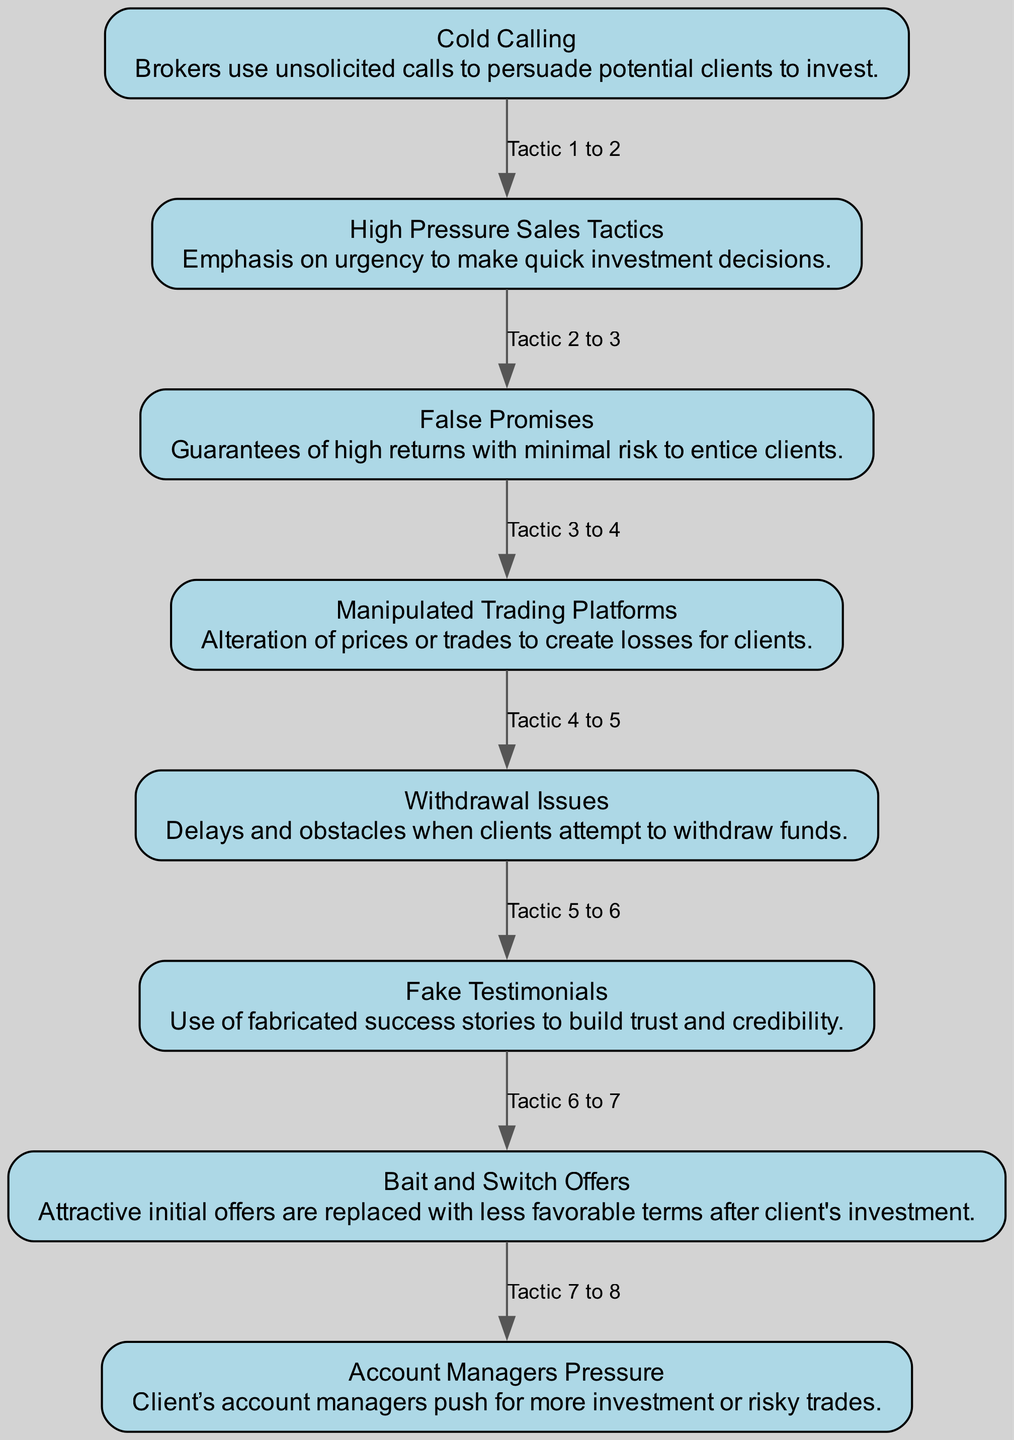What is the first tactic listed in the diagram? The first element in the flow chart is "Cold Calling," which serves as the starting point for understanding fraudulent tactics.
Answer: Cold Calling How many total tactics are presented in the diagram? Counting the elements mentioned in the diagram, there are eight tactics listed.
Answer: 8 What is the relationship between "Fake Testimonials" and "Withdrawal Issues"? "Fake Testimonials" is the sixth tactic and is followed by "Withdrawal Issues," which is the fifth tactic in the order. This indicates that they are sequential in the flow.
Answer: Sequential What tactic is associated with high returns and minimal risk? The tactic describing high returns with minimal risk is "False Promises." It aims to draw in clients by providing unrealistic expectations.
Answer: False Promises What is the last tactic mentioned in the flow chart? The final tactic in the diagram is "Account Managers Pressure," which aims to coerce clients into additional investments or risky trades.
Answer: Account Managers Pressure Which tactic involves delays when withdrawing funds? The tactic that highlights issues when attempting to withdraw funds is "Withdrawal Issues," which focuses on the challenges clients face during this process.
Answer: Withdrawal Issues Identify a tactic used to manipulate trading conditions. The tactic that manipulates trading conditions is "Manipulated Trading Platforms," where brokers alter prices or trades leading to client losses.
Answer: Manipulated Trading Platforms Which two tactics directly focus on pressuring clients? The tactics "High Pressure Sales Tactics" and "Account Managers Pressure" directly aim at pressuring clients to make swift investment decisions or increase investments.
Answer: High Pressure Sales Tactics and Account Managers Pressure 